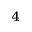Convert formula to latex. <formula><loc_0><loc_0><loc_500><loc_500>_ { 4 }</formula> 